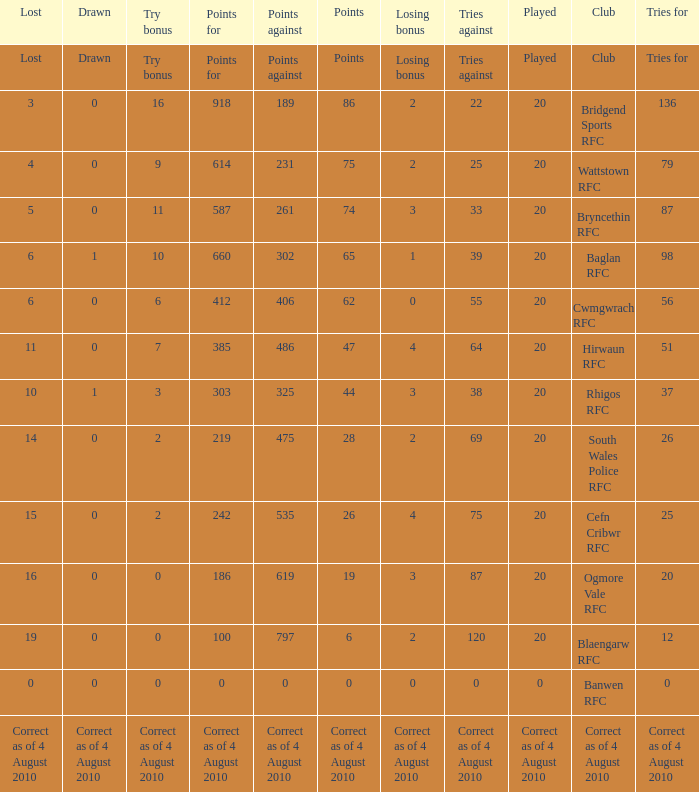What is the tries fow when losing bonus is losing bonus? Tries for. 